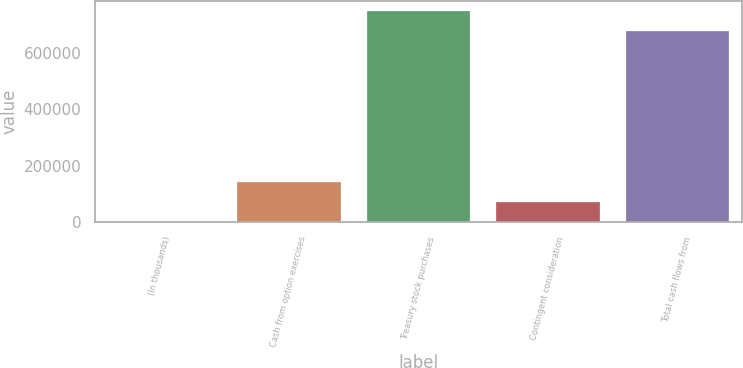Convert chart. <chart><loc_0><loc_0><loc_500><loc_500><bar_chart><fcel>(In thousands)<fcel>Cash from option exercises<fcel>Treasury stock purchases<fcel>Contingent consideration<fcel>Total cash flows from<nl><fcel>2016<fcel>141668<fcel>746503<fcel>71841.9<fcel>676677<nl></chart> 